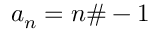Convert formula to latex. <formula><loc_0><loc_0><loc_500><loc_500>a _ { n } = n \# - 1</formula> 